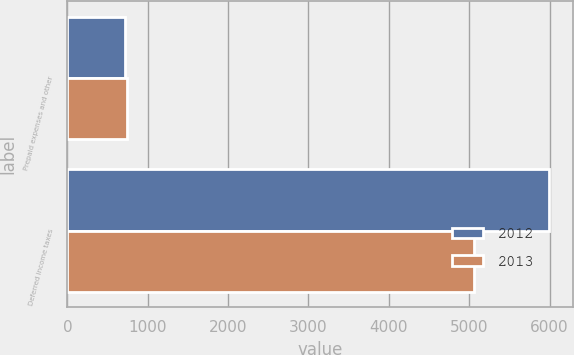Convert chart to OTSL. <chart><loc_0><loc_0><loc_500><loc_500><stacked_bar_chart><ecel><fcel>Prepaid expenses and other<fcel>Deferred income taxes<nl><fcel>2012<fcel>716<fcel>5986<nl><fcel>2013<fcel>740<fcel>5063<nl></chart> 